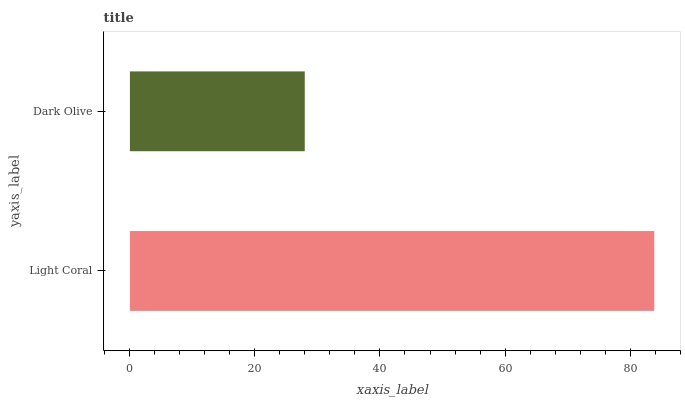Is Dark Olive the minimum?
Answer yes or no. Yes. Is Light Coral the maximum?
Answer yes or no. Yes. Is Dark Olive the maximum?
Answer yes or no. No. Is Light Coral greater than Dark Olive?
Answer yes or no. Yes. Is Dark Olive less than Light Coral?
Answer yes or no. Yes. Is Dark Olive greater than Light Coral?
Answer yes or no. No. Is Light Coral less than Dark Olive?
Answer yes or no. No. Is Light Coral the high median?
Answer yes or no. Yes. Is Dark Olive the low median?
Answer yes or no. Yes. Is Dark Olive the high median?
Answer yes or no. No. Is Light Coral the low median?
Answer yes or no. No. 